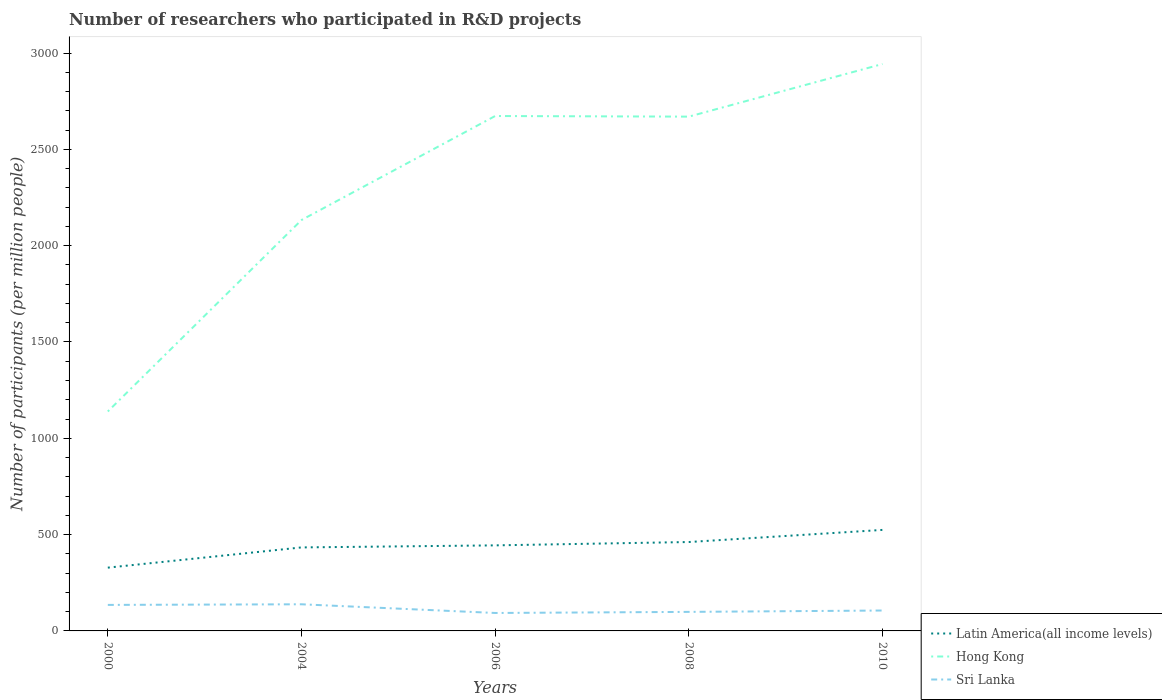Does the line corresponding to Hong Kong intersect with the line corresponding to Latin America(all income levels)?
Your response must be concise. No. Across all years, what is the maximum number of researchers who participated in R&D projects in Sri Lanka?
Provide a succinct answer. 93.18. What is the total number of researchers who participated in R&D projects in Latin America(all income levels) in the graph?
Offer a terse response. -115.63. What is the difference between the highest and the second highest number of researchers who participated in R&D projects in Latin America(all income levels)?
Provide a short and direct response. 195.88. Is the number of researchers who participated in R&D projects in Hong Kong strictly greater than the number of researchers who participated in R&D projects in Sri Lanka over the years?
Your answer should be very brief. No. How many lines are there?
Provide a succinct answer. 3. How many years are there in the graph?
Your answer should be compact. 5. What is the difference between two consecutive major ticks on the Y-axis?
Keep it short and to the point. 500. Are the values on the major ticks of Y-axis written in scientific E-notation?
Offer a very short reply. No. Does the graph contain any zero values?
Your answer should be compact. No. Does the graph contain grids?
Offer a terse response. No. What is the title of the graph?
Offer a very short reply. Number of researchers who participated in R&D projects. Does "Senegal" appear as one of the legend labels in the graph?
Your answer should be compact. No. What is the label or title of the Y-axis?
Offer a terse response. Number of participants (per million people). What is the Number of participants (per million people) in Latin America(all income levels) in 2000?
Your answer should be compact. 328.51. What is the Number of participants (per million people) in Hong Kong in 2000?
Give a very brief answer. 1139.23. What is the Number of participants (per million people) in Sri Lanka in 2000?
Provide a succinct answer. 135.06. What is the Number of participants (per million people) of Latin America(all income levels) in 2004?
Make the answer very short. 433.5. What is the Number of participants (per million people) in Hong Kong in 2004?
Offer a terse response. 2133.09. What is the Number of participants (per million people) of Sri Lanka in 2004?
Provide a succinct answer. 138.28. What is the Number of participants (per million people) in Latin America(all income levels) in 2006?
Give a very brief answer. 444.14. What is the Number of participants (per million people) in Hong Kong in 2006?
Ensure brevity in your answer.  2673.06. What is the Number of participants (per million people) of Sri Lanka in 2006?
Ensure brevity in your answer.  93.18. What is the Number of participants (per million people) of Latin America(all income levels) in 2008?
Provide a succinct answer. 461.5. What is the Number of participants (per million people) of Hong Kong in 2008?
Provide a short and direct response. 2669.9. What is the Number of participants (per million people) in Sri Lanka in 2008?
Your answer should be compact. 98.85. What is the Number of participants (per million people) in Latin America(all income levels) in 2010?
Your answer should be very brief. 524.4. What is the Number of participants (per million people) of Hong Kong in 2010?
Your answer should be compact. 2942.99. What is the Number of participants (per million people) of Sri Lanka in 2010?
Offer a terse response. 105.93. Across all years, what is the maximum Number of participants (per million people) of Latin America(all income levels)?
Offer a terse response. 524.4. Across all years, what is the maximum Number of participants (per million people) in Hong Kong?
Ensure brevity in your answer.  2942.99. Across all years, what is the maximum Number of participants (per million people) of Sri Lanka?
Give a very brief answer. 138.28. Across all years, what is the minimum Number of participants (per million people) in Latin America(all income levels)?
Provide a short and direct response. 328.51. Across all years, what is the minimum Number of participants (per million people) in Hong Kong?
Your answer should be compact. 1139.23. Across all years, what is the minimum Number of participants (per million people) of Sri Lanka?
Provide a short and direct response. 93.18. What is the total Number of participants (per million people) of Latin America(all income levels) in the graph?
Ensure brevity in your answer.  2192.04. What is the total Number of participants (per million people) of Hong Kong in the graph?
Offer a terse response. 1.16e+04. What is the total Number of participants (per million people) in Sri Lanka in the graph?
Provide a short and direct response. 571.3. What is the difference between the Number of participants (per million people) of Latin America(all income levels) in 2000 and that in 2004?
Your answer should be very brief. -104.98. What is the difference between the Number of participants (per million people) of Hong Kong in 2000 and that in 2004?
Your answer should be very brief. -993.86. What is the difference between the Number of participants (per million people) in Sri Lanka in 2000 and that in 2004?
Make the answer very short. -3.21. What is the difference between the Number of participants (per million people) in Latin America(all income levels) in 2000 and that in 2006?
Your response must be concise. -115.63. What is the difference between the Number of participants (per million people) of Hong Kong in 2000 and that in 2006?
Offer a terse response. -1533.82. What is the difference between the Number of participants (per million people) in Sri Lanka in 2000 and that in 2006?
Your answer should be compact. 41.89. What is the difference between the Number of participants (per million people) of Latin America(all income levels) in 2000 and that in 2008?
Offer a very short reply. -132.99. What is the difference between the Number of participants (per million people) of Hong Kong in 2000 and that in 2008?
Offer a very short reply. -1530.66. What is the difference between the Number of participants (per million people) in Sri Lanka in 2000 and that in 2008?
Your answer should be very brief. 36.21. What is the difference between the Number of participants (per million people) in Latin America(all income levels) in 2000 and that in 2010?
Provide a succinct answer. -195.88. What is the difference between the Number of participants (per million people) in Hong Kong in 2000 and that in 2010?
Keep it short and to the point. -1803.75. What is the difference between the Number of participants (per million people) of Sri Lanka in 2000 and that in 2010?
Keep it short and to the point. 29.13. What is the difference between the Number of participants (per million people) in Latin America(all income levels) in 2004 and that in 2006?
Ensure brevity in your answer.  -10.65. What is the difference between the Number of participants (per million people) in Hong Kong in 2004 and that in 2006?
Make the answer very short. -539.96. What is the difference between the Number of participants (per million people) in Sri Lanka in 2004 and that in 2006?
Your answer should be very brief. 45.1. What is the difference between the Number of participants (per million people) of Latin America(all income levels) in 2004 and that in 2008?
Keep it short and to the point. -28. What is the difference between the Number of participants (per million people) in Hong Kong in 2004 and that in 2008?
Your answer should be very brief. -536.8. What is the difference between the Number of participants (per million people) of Sri Lanka in 2004 and that in 2008?
Make the answer very short. 39.43. What is the difference between the Number of participants (per million people) in Latin America(all income levels) in 2004 and that in 2010?
Ensure brevity in your answer.  -90.9. What is the difference between the Number of participants (per million people) of Hong Kong in 2004 and that in 2010?
Give a very brief answer. -809.89. What is the difference between the Number of participants (per million people) in Sri Lanka in 2004 and that in 2010?
Your answer should be very brief. 32.34. What is the difference between the Number of participants (per million people) of Latin America(all income levels) in 2006 and that in 2008?
Make the answer very short. -17.35. What is the difference between the Number of participants (per million people) in Hong Kong in 2006 and that in 2008?
Provide a short and direct response. 3.16. What is the difference between the Number of participants (per million people) of Sri Lanka in 2006 and that in 2008?
Provide a short and direct response. -5.67. What is the difference between the Number of participants (per million people) in Latin America(all income levels) in 2006 and that in 2010?
Offer a terse response. -80.25. What is the difference between the Number of participants (per million people) of Hong Kong in 2006 and that in 2010?
Make the answer very short. -269.93. What is the difference between the Number of participants (per million people) in Sri Lanka in 2006 and that in 2010?
Provide a short and direct response. -12.76. What is the difference between the Number of participants (per million people) of Latin America(all income levels) in 2008 and that in 2010?
Provide a short and direct response. -62.9. What is the difference between the Number of participants (per million people) in Hong Kong in 2008 and that in 2010?
Provide a short and direct response. -273.09. What is the difference between the Number of participants (per million people) in Sri Lanka in 2008 and that in 2010?
Ensure brevity in your answer.  -7.08. What is the difference between the Number of participants (per million people) in Latin America(all income levels) in 2000 and the Number of participants (per million people) in Hong Kong in 2004?
Keep it short and to the point. -1804.58. What is the difference between the Number of participants (per million people) of Latin America(all income levels) in 2000 and the Number of participants (per million people) of Sri Lanka in 2004?
Make the answer very short. 190.24. What is the difference between the Number of participants (per million people) of Hong Kong in 2000 and the Number of participants (per million people) of Sri Lanka in 2004?
Your answer should be very brief. 1000.96. What is the difference between the Number of participants (per million people) in Latin America(all income levels) in 2000 and the Number of participants (per million people) in Hong Kong in 2006?
Your response must be concise. -2344.55. What is the difference between the Number of participants (per million people) of Latin America(all income levels) in 2000 and the Number of participants (per million people) of Sri Lanka in 2006?
Provide a short and direct response. 235.34. What is the difference between the Number of participants (per million people) in Hong Kong in 2000 and the Number of participants (per million people) in Sri Lanka in 2006?
Provide a succinct answer. 1046.06. What is the difference between the Number of participants (per million people) in Latin America(all income levels) in 2000 and the Number of participants (per million people) in Hong Kong in 2008?
Offer a terse response. -2341.38. What is the difference between the Number of participants (per million people) in Latin America(all income levels) in 2000 and the Number of participants (per million people) in Sri Lanka in 2008?
Your answer should be compact. 229.66. What is the difference between the Number of participants (per million people) of Hong Kong in 2000 and the Number of participants (per million people) of Sri Lanka in 2008?
Provide a succinct answer. 1040.39. What is the difference between the Number of participants (per million people) in Latin America(all income levels) in 2000 and the Number of participants (per million people) in Hong Kong in 2010?
Your answer should be compact. -2614.48. What is the difference between the Number of participants (per million people) of Latin America(all income levels) in 2000 and the Number of participants (per million people) of Sri Lanka in 2010?
Offer a terse response. 222.58. What is the difference between the Number of participants (per million people) in Hong Kong in 2000 and the Number of participants (per million people) in Sri Lanka in 2010?
Your answer should be very brief. 1033.3. What is the difference between the Number of participants (per million people) of Latin America(all income levels) in 2004 and the Number of participants (per million people) of Hong Kong in 2006?
Provide a short and direct response. -2239.56. What is the difference between the Number of participants (per million people) in Latin America(all income levels) in 2004 and the Number of participants (per million people) in Sri Lanka in 2006?
Make the answer very short. 340.32. What is the difference between the Number of participants (per million people) in Hong Kong in 2004 and the Number of participants (per million people) in Sri Lanka in 2006?
Your answer should be compact. 2039.92. What is the difference between the Number of participants (per million people) in Latin America(all income levels) in 2004 and the Number of participants (per million people) in Hong Kong in 2008?
Keep it short and to the point. -2236.4. What is the difference between the Number of participants (per million people) in Latin America(all income levels) in 2004 and the Number of participants (per million people) in Sri Lanka in 2008?
Offer a very short reply. 334.65. What is the difference between the Number of participants (per million people) in Hong Kong in 2004 and the Number of participants (per million people) in Sri Lanka in 2008?
Offer a very short reply. 2034.24. What is the difference between the Number of participants (per million people) in Latin America(all income levels) in 2004 and the Number of participants (per million people) in Hong Kong in 2010?
Give a very brief answer. -2509.49. What is the difference between the Number of participants (per million people) in Latin America(all income levels) in 2004 and the Number of participants (per million people) in Sri Lanka in 2010?
Your answer should be compact. 327.56. What is the difference between the Number of participants (per million people) of Hong Kong in 2004 and the Number of participants (per million people) of Sri Lanka in 2010?
Provide a short and direct response. 2027.16. What is the difference between the Number of participants (per million people) in Latin America(all income levels) in 2006 and the Number of participants (per million people) in Hong Kong in 2008?
Ensure brevity in your answer.  -2225.75. What is the difference between the Number of participants (per million people) in Latin America(all income levels) in 2006 and the Number of participants (per million people) in Sri Lanka in 2008?
Your response must be concise. 345.29. What is the difference between the Number of participants (per million people) of Hong Kong in 2006 and the Number of participants (per million people) of Sri Lanka in 2008?
Your response must be concise. 2574.21. What is the difference between the Number of participants (per million people) of Latin America(all income levels) in 2006 and the Number of participants (per million people) of Hong Kong in 2010?
Your response must be concise. -2498.85. What is the difference between the Number of participants (per million people) in Latin America(all income levels) in 2006 and the Number of participants (per million people) in Sri Lanka in 2010?
Your response must be concise. 338.21. What is the difference between the Number of participants (per million people) of Hong Kong in 2006 and the Number of participants (per million people) of Sri Lanka in 2010?
Your response must be concise. 2567.12. What is the difference between the Number of participants (per million people) in Latin America(all income levels) in 2008 and the Number of participants (per million people) in Hong Kong in 2010?
Provide a short and direct response. -2481.49. What is the difference between the Number of participants (per million people) of Latin America(all income levels) in 2008 and the Number of participants (per million people) of Sri Lanka in 2010?
Your answer should be compact. 355.56. What is the difference between the Number of participants (per million people) in Hong Kong in 2008 and the Number of participants (per million people) in Sri Lanka in 2010?
Ensure brevity in your answer.  2563.96. What is the average Number of participants (per million people) of Latin America(all income levels) per year?
Offer a very short reply. 438.41. What is the average Number of participants (per million people) in Hong Kong per year?
Your response must be concise. 2311.65. What is the average Number of participants (per million people) of Sri Lanka per year?
Give a very brief answer. 114.26. In the year 2000, what is the difference between the Number of participants (per million people) of Latin America(all income levels) and Number of participants (per million people) of Hong Kong?
Keep it short and to the point. -810.72. In the year 2000, what is the difference between the Number of participants (per million people) of Latin America(all income levels) and Number of participants (per million people) of Sri Lanka?
Provide a succinct answer. 193.45. In the year 2000, what is the difference between the Number of participants (per million people) in Hong Kong and Number of participants (per million people) in Sri Lanka?
Provide a short and direct response. 1004.17. In the year 2004, what is the difference between the Number of participants (per million people) in Latin America(all income levels) and Number of participants (per million people) in Hong Kong?
Keep it short and to the point. -1699.6. In the year 2004, what is the difference between the Number of participants (per million people) in Latin America(all income levels) and Number of participants (per million people) in Sri Lanka?
Keep it short and to the point. 295.22. In the year 2004, what is the difference between the Number of participants (per million people) in Hong Kong and Number of participants (per million people) in Sri Lanka?
Ensure brevity in your answer.  1994.82. In the year 2006, what is the difference between the Number of participants (per million people) in Latin America(all income levels) and Number of participants (per million people) in Hong Kong?
Keep it short and to the point. -2228.91. In the year 2006, what is the difference between the Number of participants (per million people) in Latin America(all income levels) and Number of participants (per million people) in Sri Lanka?
Provide a short and direct response. 350.97. In the year 2006, what is the difference between the Number of participants (per million people) of Hong Kong and Number of participants (per million people) of Sri Lanka?
Keep it short and to the point. 2579.88. In the year 2008, what is the difference between the Number of participants (per million people) of Latin America(all income levels) and Number of participants (per million people) of Hong Kong?
Your response must be concise. -2208.4. In the year 2008, what is the difference between the Number of participants (per million people) in Latin America(all income levels) and Number of participants (per million people) in Sri Lanka?
Provide a succinct answer. 362.65. In the year 2008, what is the difference between the Number of participants (per million people) in Hong Kong and Number of participants (per million people) in Sri Lanka?
Offer a terse response. 2571.05. In the year 2010, what is the difference between the Number of participants (per million people) in Latin America(all income levels) and Number of participants (per million people) in Hong Kong?
Make the answer very short. -2418.59. In the year 2010, what is the difference between the Number of participants (per million people) in Latin America(all income levels) and Number of participants (per million people) in Sri Lanka?
Give a very brief answer. 418.46. In the year 2010, what is the difference between the Number of participants (per million people) in Hong Kong and Number of participants (per million people) in Sri Lanka?
Your answer should be very brief. 2837.06. What is the ratio of the Number of participants (per million people) in Latin America(all income levels) in 2000 to that in 2004?
Offer a terse response. 0.76. What is the ratio of the Number of participants (per million people) in Hong Kong in 2000 to that in 2004?
Keep it short and to the point. 0.53. What is the ratio of the Number of participants (per million people) of Sri Lanka in 2000 to that in 2004?
Ensure brevity in your answer.  0.98. What is the ratio of the Number of participants (per million people) in Latin America(all income levels) in 2000 to that in 2006?
Offer a terse response. 0.74. What is the ratio of the Number of participants (per million people) in Hong Kong in 2000 to that in 2006?
Keep it short and to the point. 0.43. What is the ratio of the Number of participants (per million people) of Sri Lanka in 2000 to that in 2006?
Provide a succinct answer. 1.45. What is the ratio of the Number of participants (per million people) in Latin America(all income levels) in 2000 to that in 2008?
Make the answer very short. 0.71. What is the ratio of the Number of participants (per million people) of Hong Kong in 2000 to that in 2008?
Give a very brief answer. 0.43. What is the ratio of the Number of participants (per million people) in Sri Lanka in 2000 to that in 2008?
Ensure brevity in your answer.  1.37. What is the ratio of the Number of participants (per million people) in Latin America(all income levels) in 2000 to that in 2010?
Your response must be concise. 0.63. What is the ratio of the Number of participants (per million people) in Hong Kong in 2000 to that in 2010?
Make the answer very short. 0.39. What is the ratio of the Number of participants (per million people) in Sri Lanka in 2000 to that in 2010?
Your answer should be very brief. 1.27. What is the ratio of the Number of participants (per million people) of Latin America(all income levels) in 2004 to that in 2006?
Provide a short and direct response. 0.98. What is the ratio of the Number of participants (per million people) in Hong Kong in 2004 to that in 2006?
Make the answer very short. 0.8. What is the ratio of the Number of participants (per million people) in Sri Lanka in 2004 to that in 2006?
Your answer should be very brief. 1.48. What is the ratio of the Number of participants (per million people) in Latin America(all income levels) in 2004 to that in 2008?
Ensure brevity in your answer.  0.94. What is the ratio of the Number of participants (per million people) in Hong Kong in 2004 to that in 2008?
Offer a very short reply. 0.8. What is the ratio of the Number of participants (per million people) of Sri Lanka in 2004 to that in 2008?
Make the answer very short. 1.4. What is the ratio of the Number of participants (per million people) of Latin America(all income levels) in 2004 to that in 2010?
Offer a very short reply. 0.83. What is the ratio of the Number of participants (per million people) of Hong Kong in 2004 to that in 2010?
Your response must be concise. 0.72. What is the ratio of the Number of participants (per million people) in Sri Lanka in 2004 to that in 2010?
Offer a very short reply. 1.31. What is the ratio of the Number of participants (per million people) in Latin America(all income levels) in 2006 to that in 2008?
Provide a short and direct response. 0.96. What is the ratio of the Number of participants (per million people) of Hong Kong in 2006 to that in 2008?
Offer a terse response. 1. What is the ratio of the Number of participants (per million people) in Sri Lanka in 2006 to that in 2008?
Give a very brief answer. 0.94. What is the ratio of the Number of participants (per million people) in Latin America(all income levels) in 2006 to that in 2010?
Provide a short and direct response. 0.85. What is the ratio of the Number of participants (per million people) of Hong Kong in 2006 to that in 2010?
Offer a very short reply. 0.91. What is the ratio of the Number of participants (per million people) in Sri Lanka in 2006 to that in 2010?
Keep it short and to the point. 0.88. What is the ratio of the Number of participants (per million people) of Latin America(all income levels) in 2008 to that in 2010?
Ensure brevity in your answer.  0.88. What is the ratio of the Number of participants (per million people) in Hong Kong in 2008 to that in 2010?
Keep it short and to the point. 0.91. What is the ratio of the Number of participants (per million people) of Sri Lanka in 2008 to that in 2010?
Offer a very short reply. 0.93. What is the difference between the highest and the second highest Number of participants (per million people) of Latin America(all income levels)?
Provide a short and direct response. 62.9. What is the difference between the highest and the second highest Number of participants (per million people) in Hong Kong?
Keep it short and to the point. 269.93. What is the difference between the highest and the second highest Number of participants (per million people) of Sri Lanka?
Provide a short and direct response. 3.21. What is the difference between the highest and the lowest Number of participants (per million people) of Latin America(all income levels)?
Provide a succinct answer. 195.88. What is the difference between the highest and the lowest Number of participants (per million people) in Hong Kong?
Keep it short and to the point. 1803.75. What is the difference between the highest and the lowest Number of participants (per million people) in Sri Lanka?
Your answer should be compact. 45.1. 